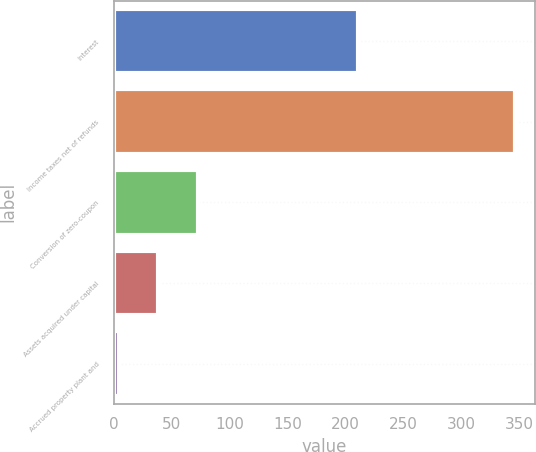Convert chart to OTSL. <chart><loc_0><loc_0><loc_500><loc_500><bar_chart><fcel>Interest<fcel>Income taxes net of refunds<fcel>Conversion of zero-coupon<fcel>Assets acquired under capital<fcel>Accrued property plant and<nl><fcel>210.7<fcel>345.7<fcel>72.66<fcel>38.53<fcel>4.4<nl></chart> 